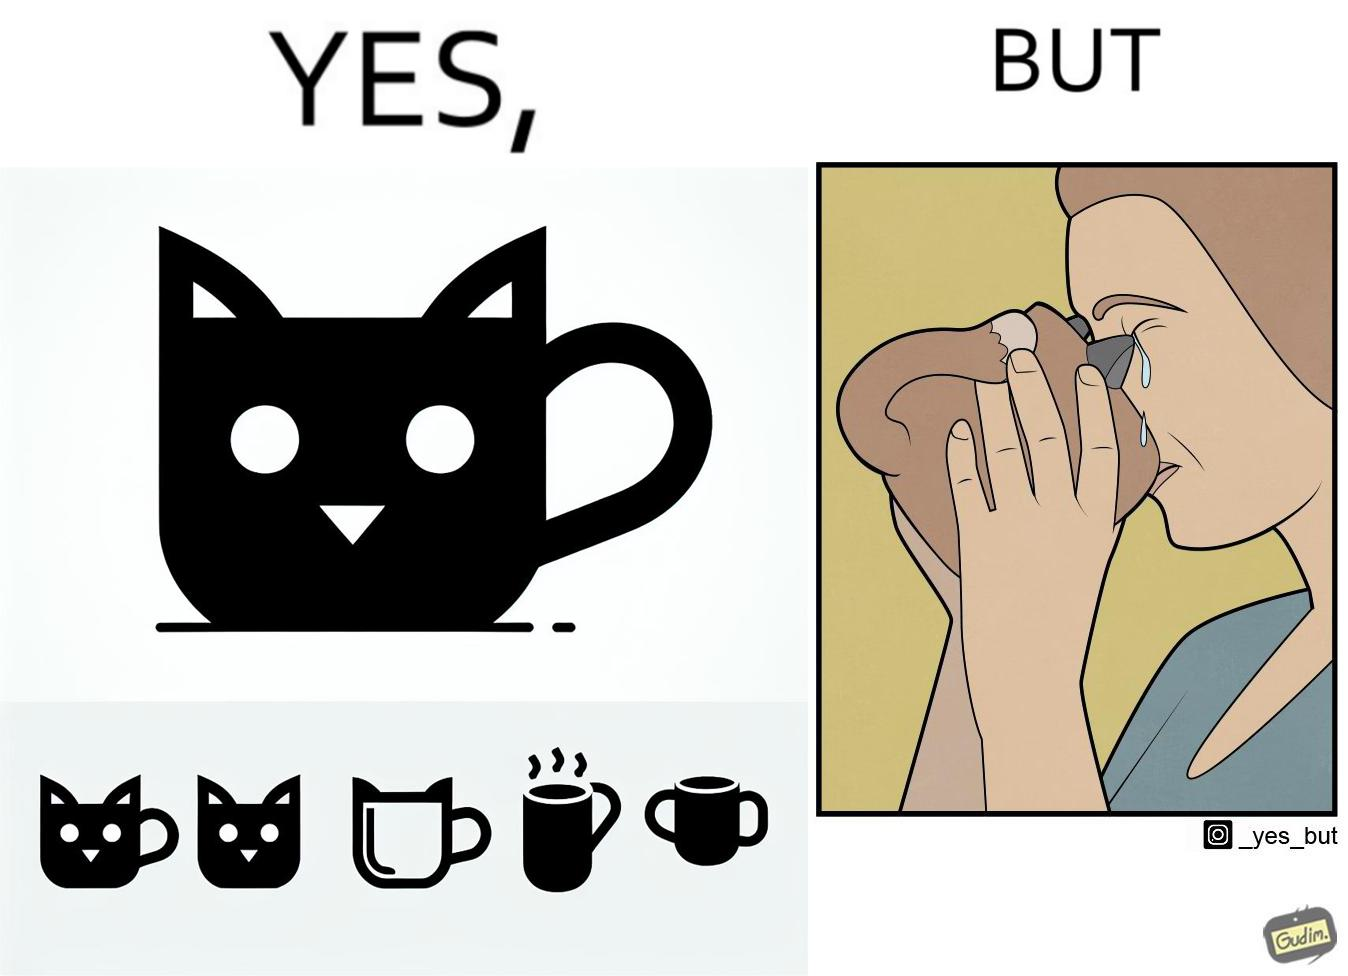Is there satirical content in this image? Yes, this image is satirical. 